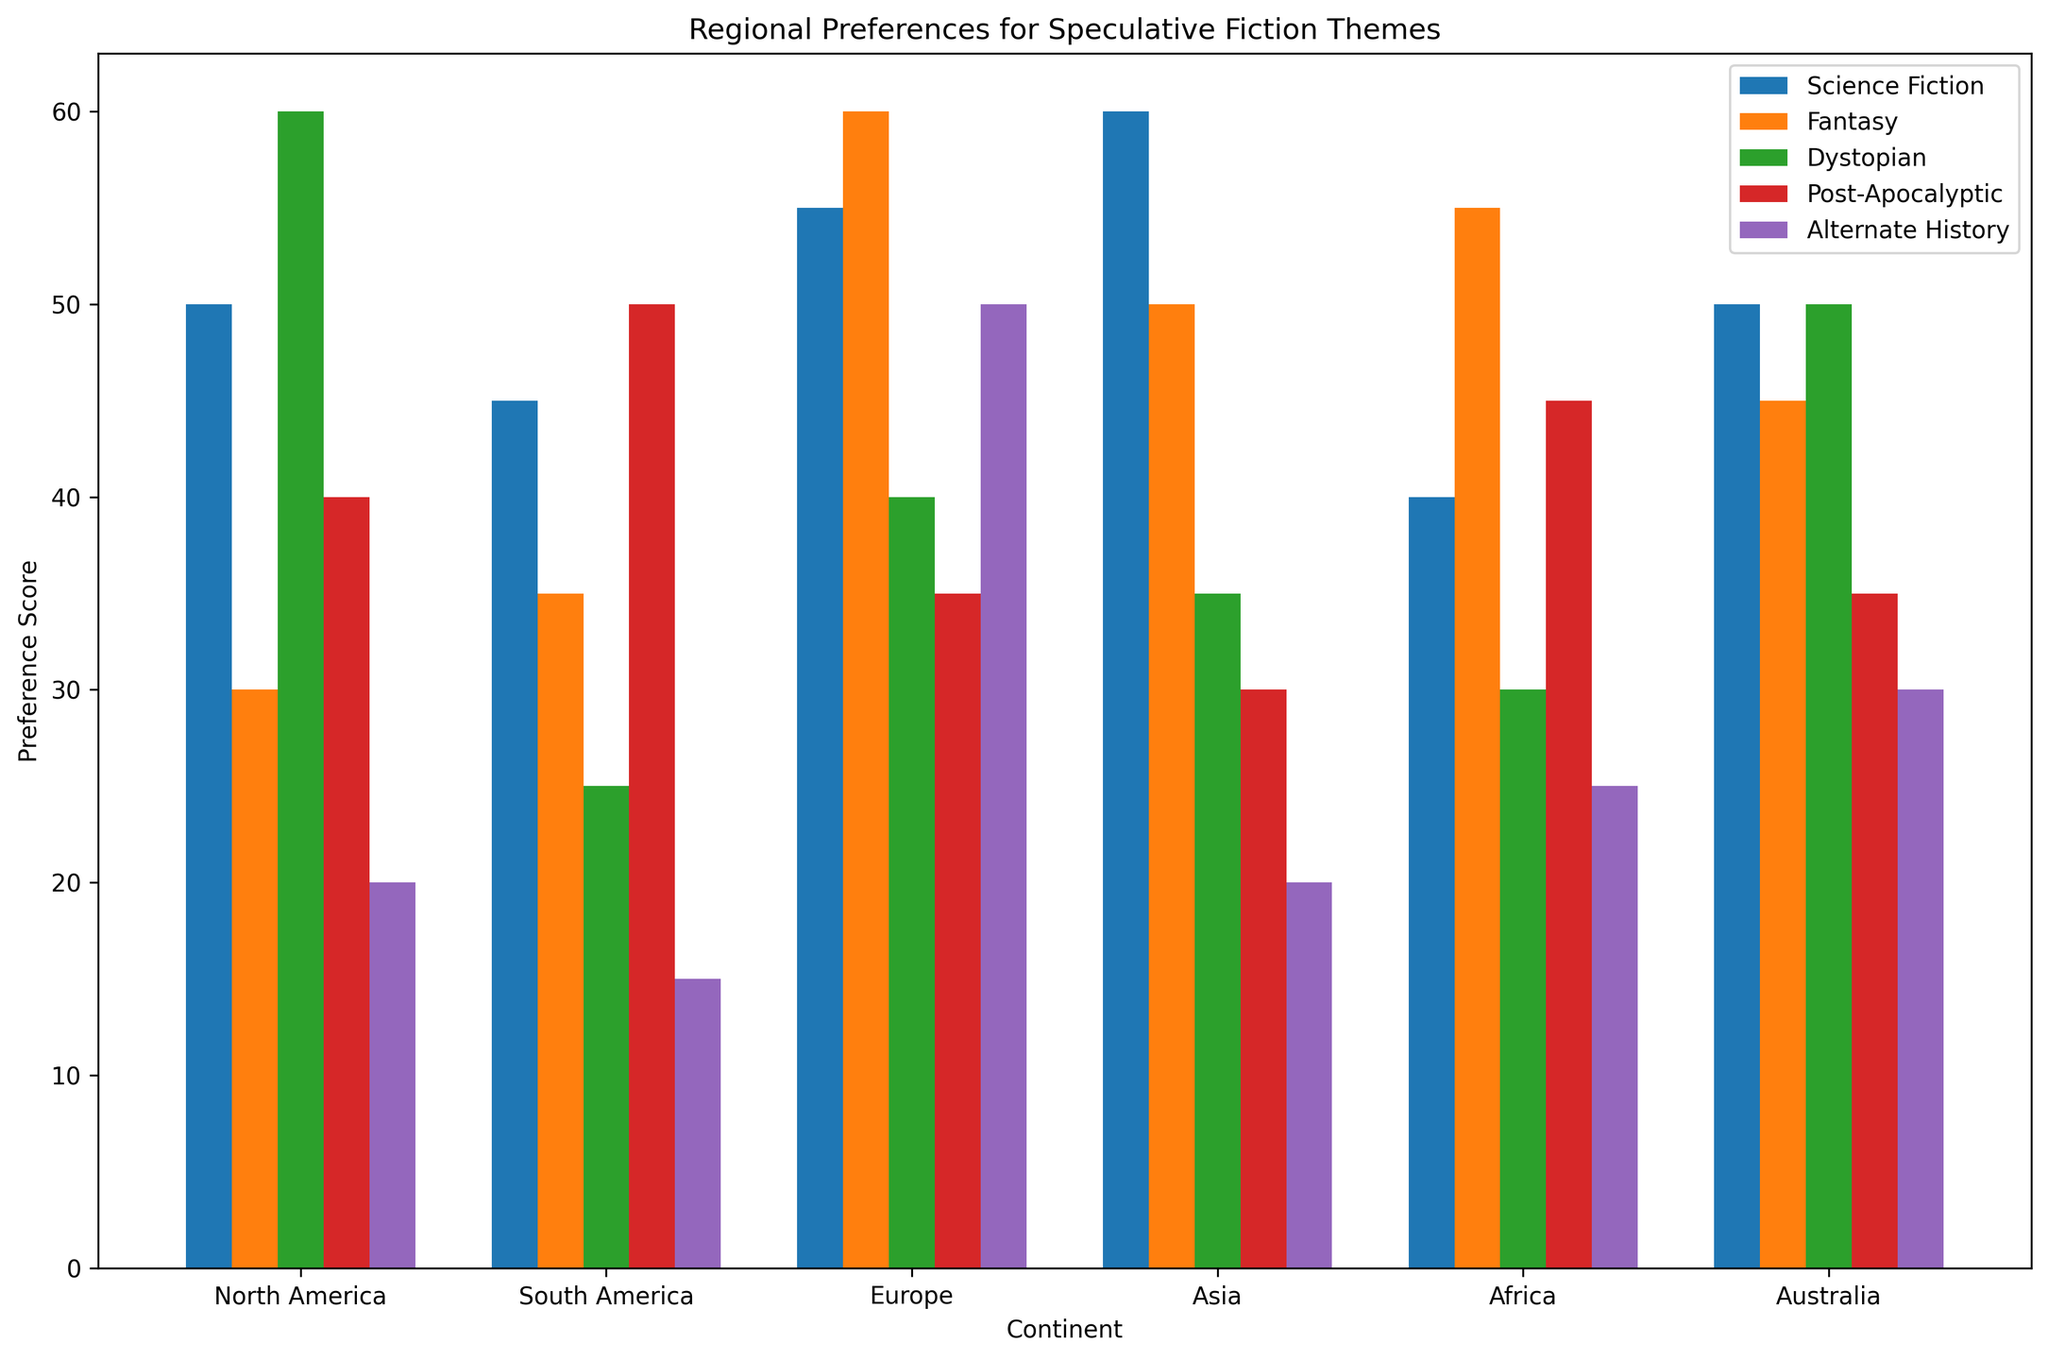Which continent has the highest preference for Fantasy? By visually comparing the height of the Fantasy bars, Europe has the highest bar for Fantasy.
Answer: Europe Which continent has the lowest preference for Alternate History? By visually comparing the height of the Alternate History bars, South America has the shortest bar for Alternate History.
Answer: South America Which continent has a higher preference for Post-Apocalyptic themes, North America or South America? By comparing the height of the Post-Apocalyptic bars, South America's bar is higher than North America's.
Answer: South America What is the average preference score for Science Fiction across all continents? Sum the preference scores for Science Fiction (50 + 45 + 55 + 60 + 40 + 50) and divide by the number of continents (6). The result is (300 / 6 =) 50.
Answer: 50 What is the difference in preference scores for Dystopian themes between Asia and Australia? Subtract the Dystopian score of Australia (50) from Asia's (35), resulting in (50 - 35 =) 15.
Answer: 15 Which continent has the second highest preference for Science Fiction? By visually identifying the highest and the next highest bar for Science Fiction, Asia is the highest, and Europe is the second highest.
Answer: Europe What is the sum of preference scores for Fantasy and Dystopian themes in Africa? The preference scores in Africa for Fantasy is 55 and for Dystopian is 30. Summing them gives (55 + 30 =) 85.
Answer: 85 Which continent prefers Alternate History more: Europe or Asia? Comparing the height of the Alternate History bars, Europe's bar is higher than Asia's.
Answer: Europe What is the difference between the highest and lowest preference scores for any theme within North America? The highest preference score for North America is 60 for Dystopian, and the lowest is 20 for Alternate History. The difference is (60 - 20 =) 40.
Answer: 40 Does Africa have a higher preference for Fantasy or Science Fiction? By comparing the heights of Fantasy and Science Fiction bars for Africa, the Fantasy bar is higher than the Science Fiction bar.
Answer: Fantasy 